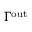<formula> <loc_0><loc_0><loc_500><loc_500>\Gamma ^ { o u t }</formula> 